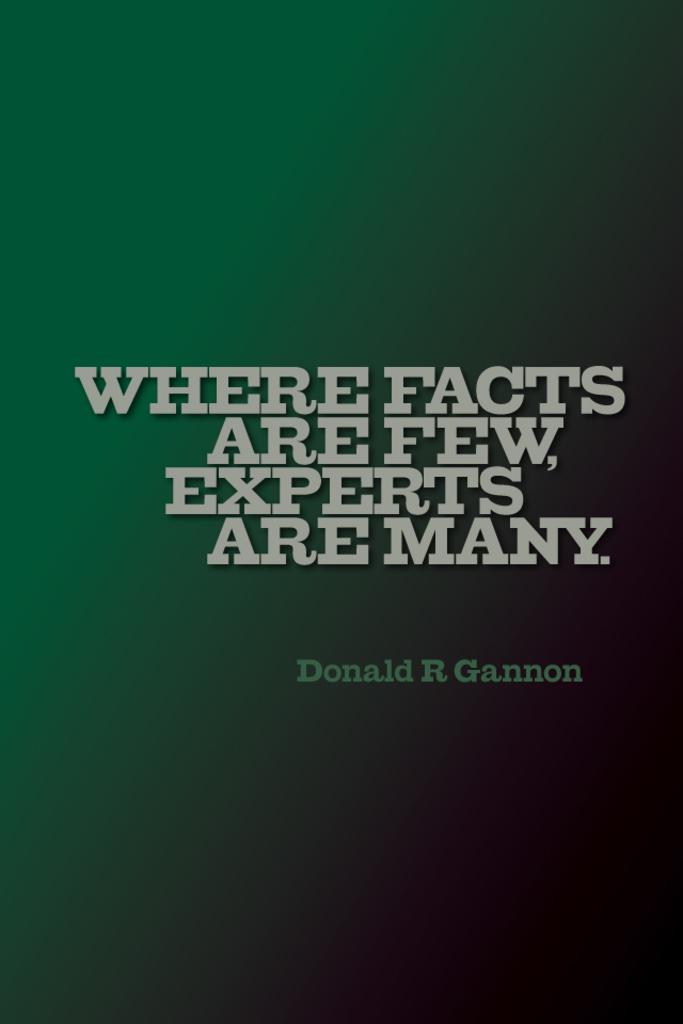<image>
Give a short and clear explanation of the subsequent image. "Where facts are few, experts are many" and Donald R. Gannon are on a green to black gradient background. 